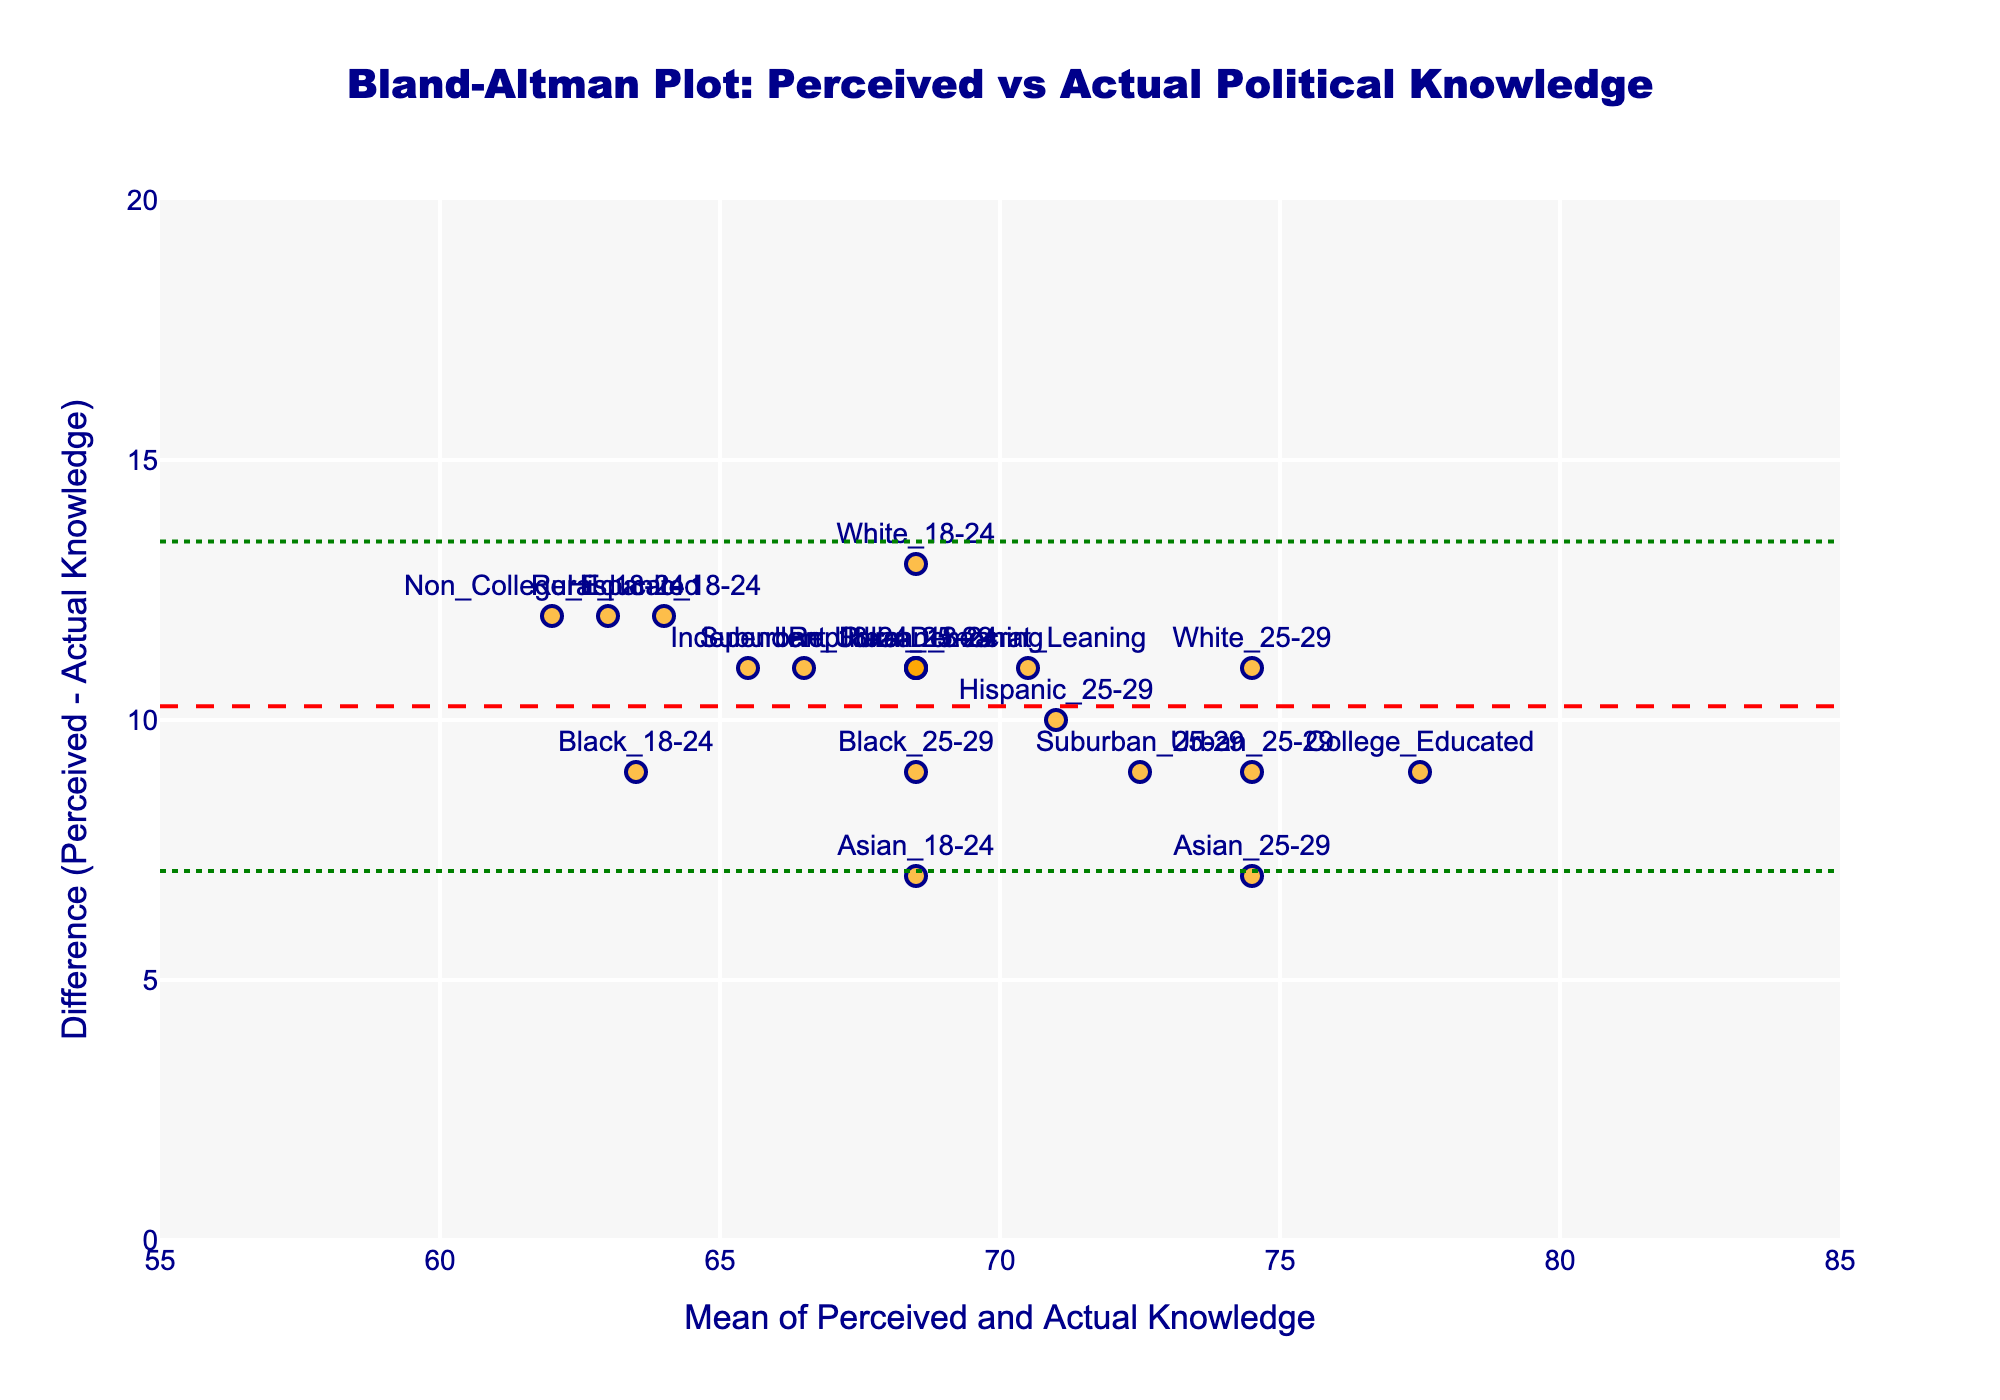How many demographics are represented in the plot? Count the number of unique data points labeled with demographic names on the plot.
Answer: 18 What is the title of the plot? Read the title displayed at the top of the figure.
Answer: Bland-Altman Plot: Perceived vs Actual Political Knowledge Which demographic has the highest perceived political knowledge? Identify the data point with the highest value on the 'Perceived_Knowledge' axis.
Answer: College_Educated Which demographic has the biggest difference between perceived and actual political knowledge? Find the data point with the largest vertical distance from the zero line (mean line).
Answer: Non_College_Educated What are the values of the upper and lower limits of agreement? Read off the positions of the horizontal dotted lines on the plot, representing the upper and lower limits of agreement.
Answer: Upper: approximately 15, Lower: approximately 5 What is the mean difference between perceived and actual political knowledge? Locate the horizontal dashed line, which represents the mean difference, and read its y-axis value.
Answer: Approximately 9 Which demographics' perceived political knowledge is overestimated by more than 10 points? Identify the data points where the difference between perceived and actual knowledge exceeds 10 on the y-axis.
Answer: Non_College_Educated, Rural_18-24, Hispanic_18-24 What is the range of the mean of perceived and actual political knowledge? Read the values at the start and end of the x-axis, which display the range of means.
Answer: 55 to 85 Does any demographic have perceived political knowledge equal to their actual political knowledge? Look for any data points that are exactly on the zero line (where difference = 0).
Answer: No Which demographic has the smallest discrepancy between perceived and actual political knowledge? Identify the data point closest to the zero line on the y-axis.
Answer: Asian_25-29 